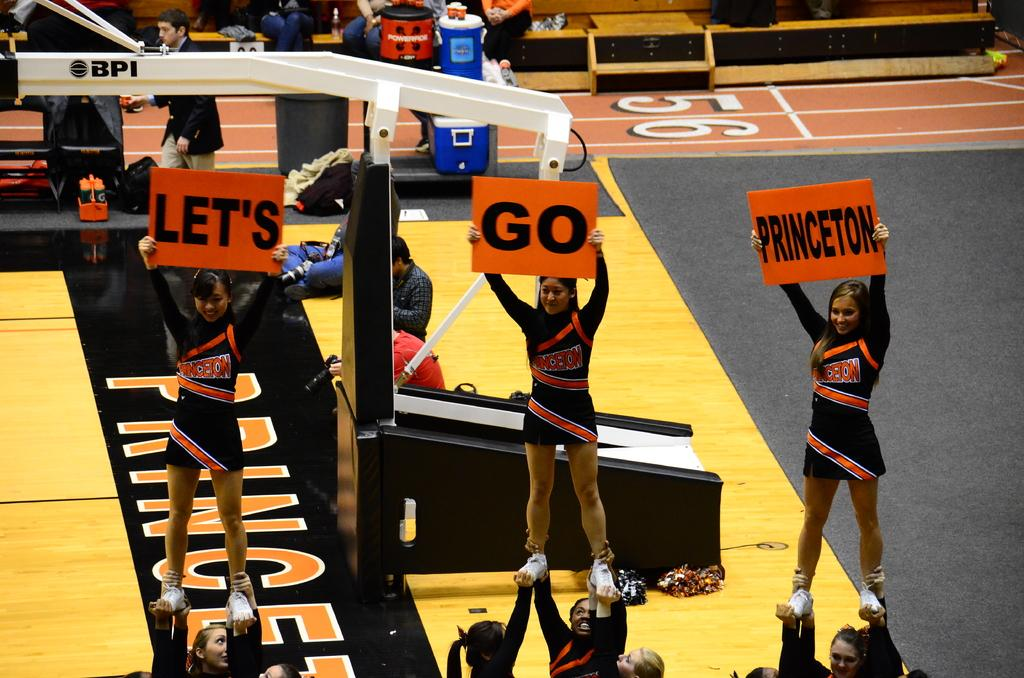Provide a one-sentence caption for the provided image. THREE CHEER LEADERS FROM PRINCETON ARE MOTIVATING THE CROWD TO CHEER FOR THEIR TEAM. 